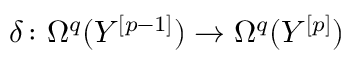Convert formula to latex. <formula><loc_0><loc_0><loc_500><loc_500>\delta \colon \Omega ^ { q } ( Y ^ { [ p - 1 ] } ) \to \Omega ^ { q } ( Y ^ { [ p ] } )</formula> 